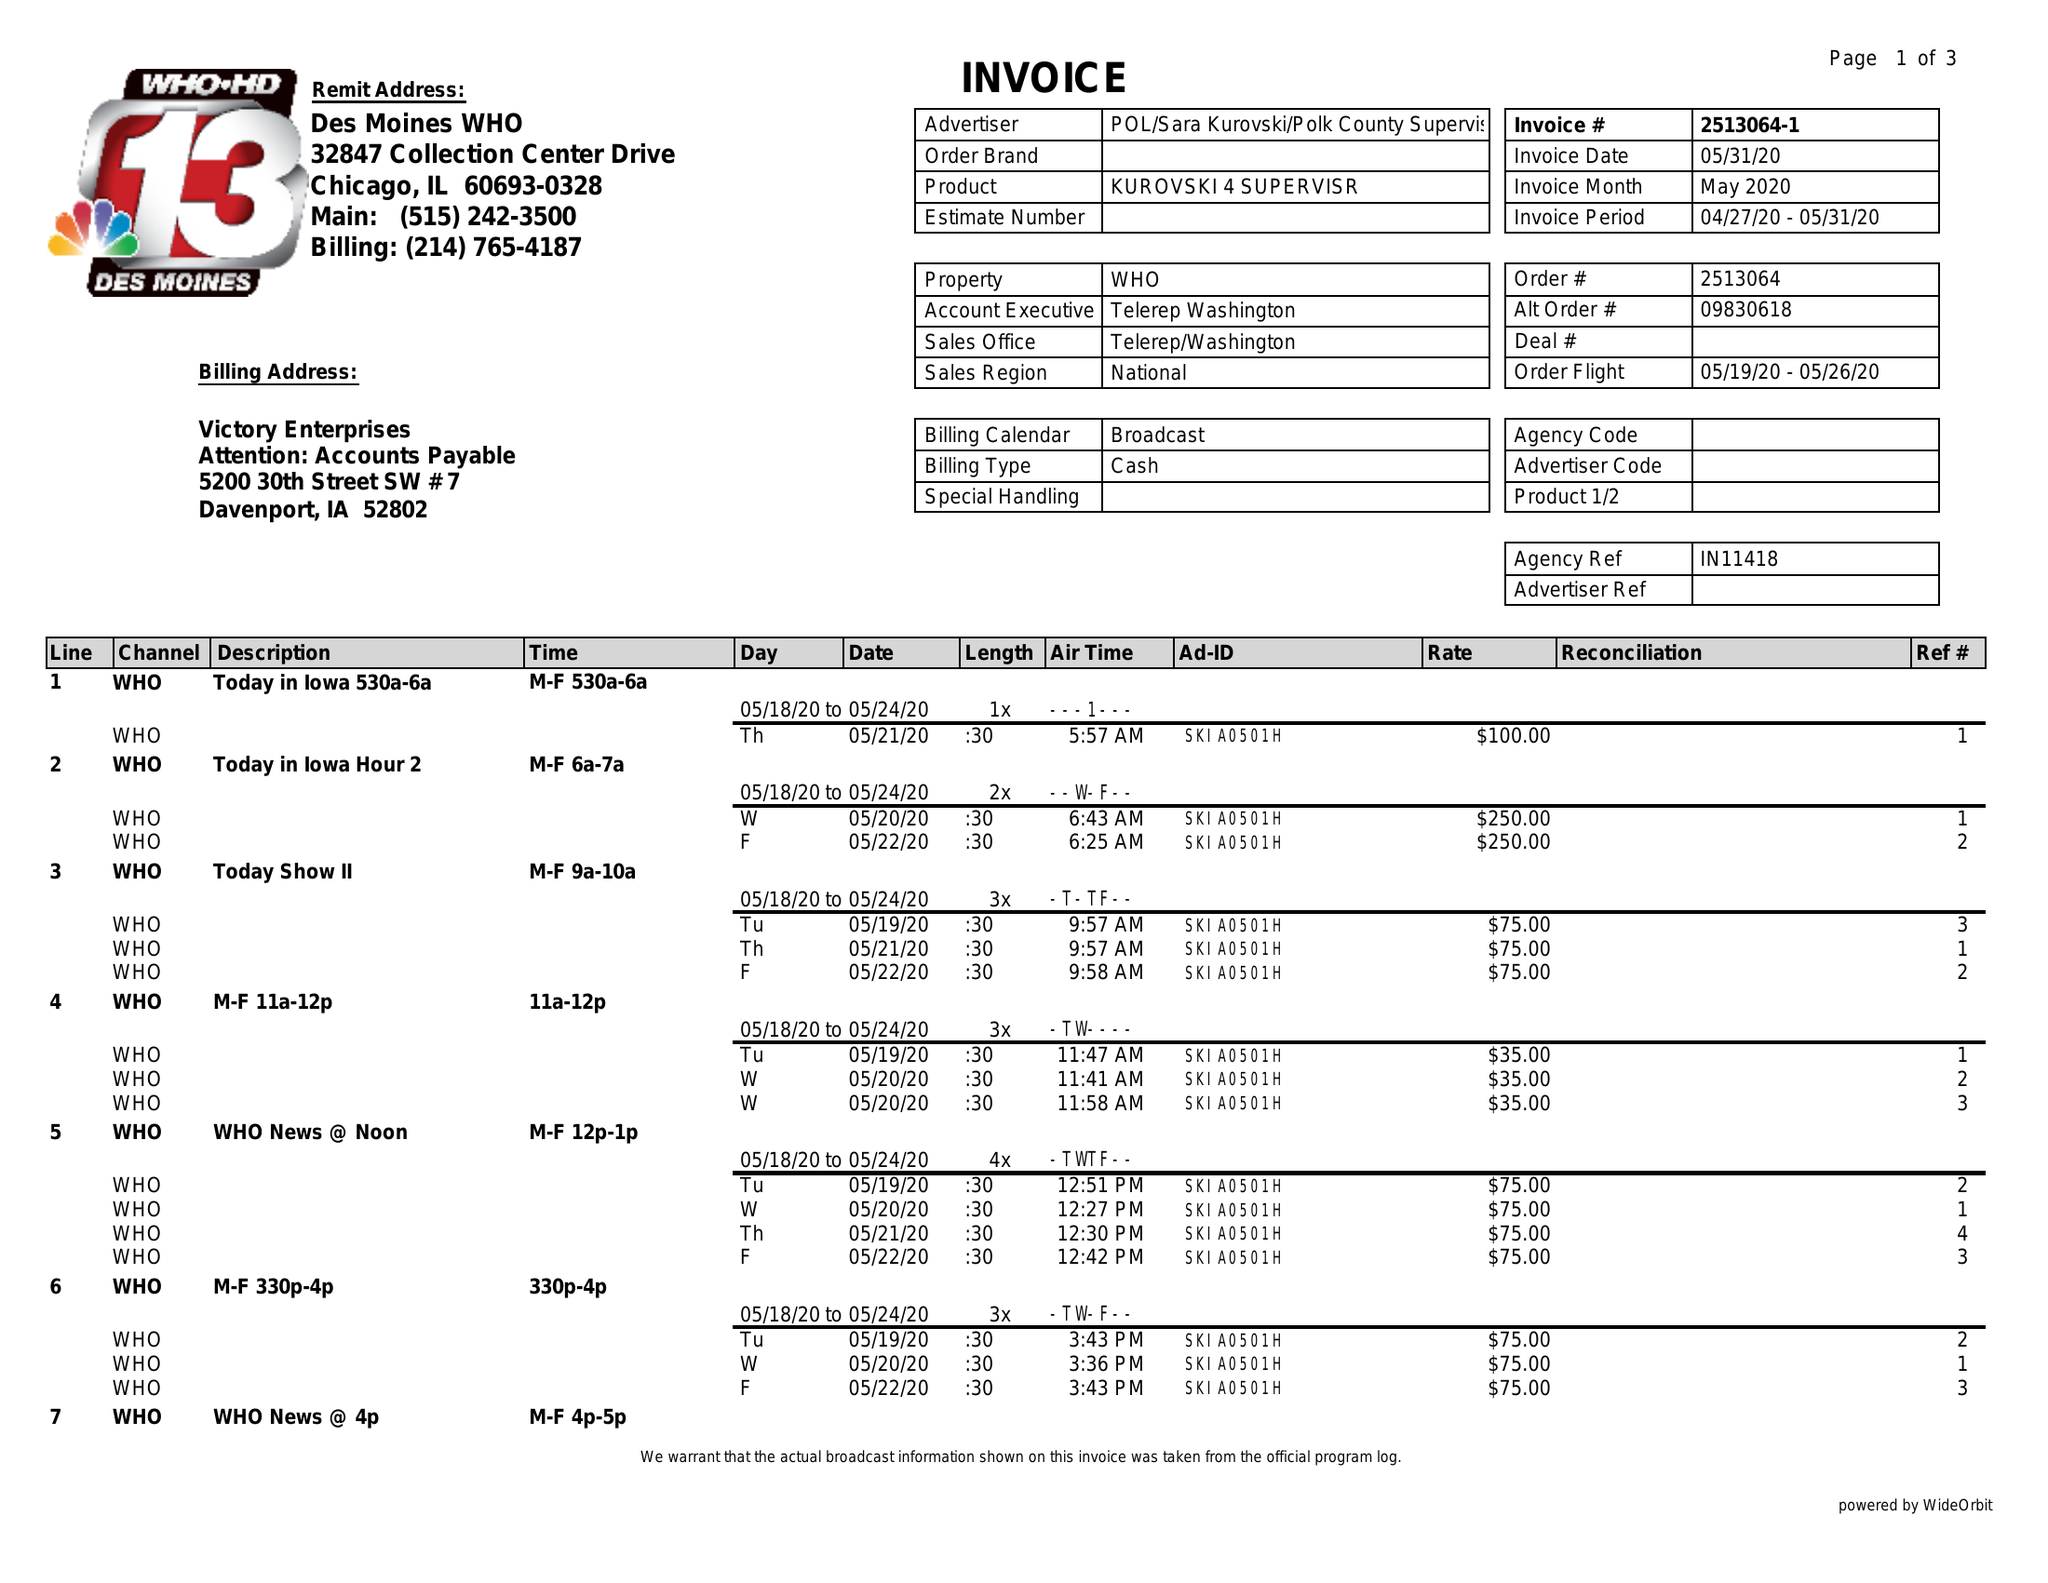What is the value for the contract_num?
Answer the question using a single word or phrase. 2513064 